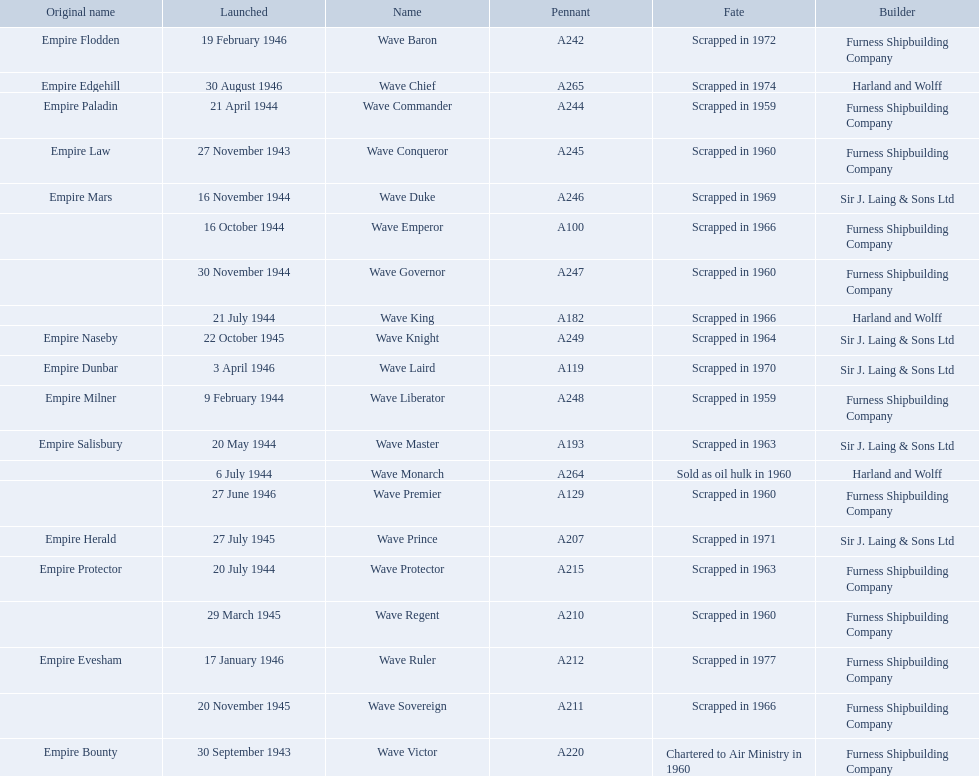What builders launched ships in november of any year? Furness Shipbuilding Company, Sir J. Laing & Sons Ltd, Furness Shipbuilding Company, Furness Shipbuilding Company. What ship builders ships had their original name's changed prior to scrapping? Furness Shipbuilding Company, Sir J. Laing & Sons Ltd. What was the name of the ship that was built in november and had its name changed prior to scrapping only 12 years after its launch? Wave Conqueror. Could you parse the entire table as a dict? {'header': ['Original name', 'Launched', 'Name', 'Pennant', 'Fate', 'Builder'], 'rows': [['Empire Flodden', '19 February 1946', 'Wave Baron', 'A242', 'Scrapped in 1972', 'Furness Shipbuilding Company'], ['Empire Edgehill', '30 August 1946', 'Wave Chief', 'A265', 'Scrapped in 1974', 'Harland and Wolff'], ['Empire Paladin', '21 April 1944', 'Wave Commander', 'A244', 'Scrapped in 1959', 'Furness Shipbuilding Company'], ['Empire Law', '27 November 1943', 'Wave Conqueror', 'A245', 'Scrapped in 1960', 'Furness Shipbuilding Company'], ['Empire Mars', '16 November 1944', 'Wave Duke', 'A246', 'Scrapped in 1969', 'Sir J. Laing & Sons Ltd'], ['', '16 October 1944', 'Wave Emperor', 'A100', 'Scrapped in 1966', 'Furness Shipbuilding Company'], ['', '30 November 1944', 'Wave Governor', 'A247', 'Scrapped in 1960', 'Furness Shipbuilding Company'], ['', '21 July 1944', 'Wave King', 'A182', 'Scrapped in 1966', 'Harland and Wolff'], ['Empire Naseby', '22 October 1945', 'Wave Knight', 'A249', 'Scrapped in 1964', 'Sir J. Laing & Sons Ltd'], ['Empire Dunbar', '3 April 1946', 'Wave Laird', 'A119', 'Scrapped in 1970', 'Sir J. Laing & Sons Ltd'], ['Empire Milner', '9 February 1944', 'Wave Liberator', 'A248', 'Scrapped in 1959', 'Furness Shipbuilding Company'], ['Empire Salisbury', '20 May 1944', 'Wave Master', 'A193', 'Scrapped in 1963', 'Sir J. Laing & Sons Ltd'], ['', '6 July 1944', 'Wave Monarch', 'A264', 'Sold as oil hulk in 1960', 'Harland and Wolff'], ['', '27 June 1946', 'Wave Premier', 'A129', 'Scrapped in 1960', 'Furness Shipbuilding Company'], ['Empire Herald', '27 July 1945', 'Wave Prince', 'A207', 'Scrapped in 1971', 'Sir J. Laing & Sons Ltd'], ['Empire Protector', '20 July 1944', 'Wave Protector', 'A215', 'Scrapped in 1963', 'Furness Shipbuilding Company'], ['', '29 March 1945', 'Wave Regent', 'A210', 'Scrapped in 1960', 'Furness Shipbuilding Company'], ['Empire Evesham', '17 January 1946', 'Wave Ruler', 'A212', 'Scrapped in 1977', 'Furness Shipbuilding Company'], ['', '20 November 1945', 'Wave Sovereign', 'A211', 'Scrapped in 1966', 'Furness Shipbuilding Company'], ['Empire Bounty', '30 September 1943', 'Wave Victor', 'A220', 'Chartered to Air Ministry in 1960', 'Furness Shipbuilding Company']]} 